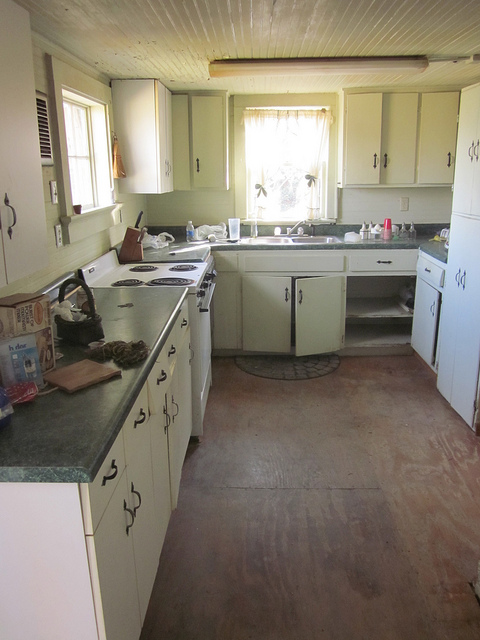<image>What color are the accent tiles? I don't know what color the accent tiles are. They could be blue, green, white, gray, or yellow. What color are the accent tiles? I don't know what color the accent tiles are. It can be seen blue, green, white, gray, yellow, or none. 